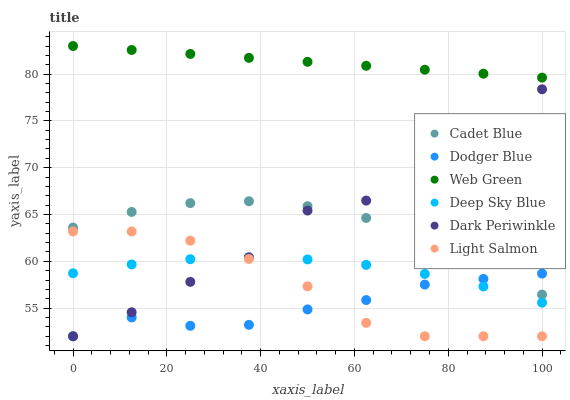Does Dodger Blue have the minimum area under the curve?
Answer yes or no. Yes. Does Web Green have the maximum area under the curve?
Answer yes or no. Yes. Does Cadet Blue have the minimum area under the curve?
Answer yes or no. No. Does Cadet Blue have the maximum area under the curve?
Answer yes or no. No. Is Web Green the smoothest?
Answer yes or no. Yes. Is Dark Periwinkle the roughest?
Answer yes or no. Yes. Is Cadet Blue the smoothest?
Answer yes or no. No. Is Cadet Blue the roughest?
Answer yes or no. No. Does Light Salmon have the lowest value?
Answer yes or no. Yes. Does Cadet Blue have the lowest value?
Answer yes or no. No. Does Web Green have the highest value?
Answer yes or no. Yes. Does Cadet Blue have the highest value?
Answer yes or no. No. Is Deep Sky Blue less than Web Green?
Answer yes or no. Yes. Is Cadet Blue greater than Deep Sky Blue?
Answer yes or no. Yes. Does Deep Sky Blue intersect Light Salmon?
Answer yes or no. Yes. Is Deep Sky Blue less than Light Salmon?
Answer yes or no. No. Is Deep Sky Blue greater than Light Salmon?
Answer yes or no. No. Does Deep Sky Blue intersect Web Green?
Answer yes or no. No. 